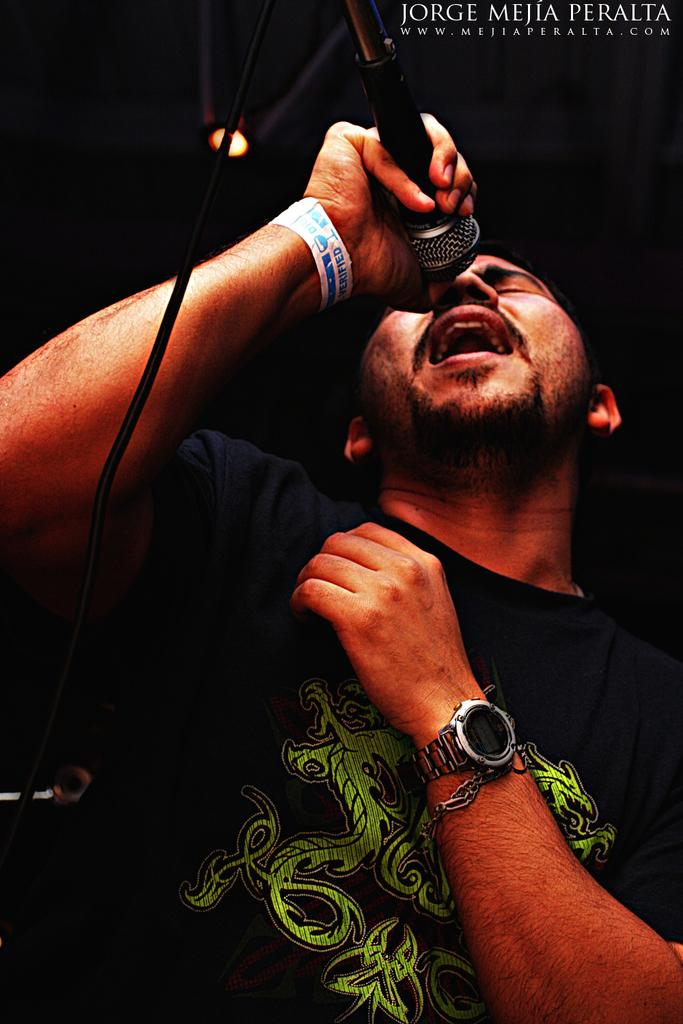Who or what is the main subject in the image? There is a person in the image. What is the person holding in the image? The person is holding a microphone. Can you describe any accessories the person is wearing? The person is wearing a watch. What else can be seen on the right side of the image? There is text on the right side of the image. What type of pest can be seen crawling on the person's arm in the image? There is no pest visible on the person's arm in the image. How does the person's involvement in society affect their actions in the image? The image does not provide any information about the person's involvement in society or how it might affect their actions. --- Facts: 1. There is a car in the image. 2. The car is red. 3. The car has four wheels. 4. There is a road in the image. 5. The road is paved. Absurd Topics: bird, ocean, mountain Conversation: What is the main subject in the image? There is a car in the image. Can you describe the color of the car? The car is red. How many wheels does the car have? The car has four wheels. What type of surface is the car driving on in the image? There is a road in the image, and it is paved. Reasoning: Let's think step by step in order to produce the conversation. We start by identifying the main subject in the image, which is the car. Then, we expand the conversation to include other details about the car, such as its color (red) and the number of wheels (four). Finally, we mention the road in the image and its surface (paved), which is another detail provided in the facts. Absurd Question/Answer: Can you see any birds flying over the ocean in the image? There is no ocean or birds visible in the image; it features a red car driving on a paved road. What type of mountain range can be seen in the background of the image? There is no mountain range visible in the image; it features a red car driving on a paved road. 